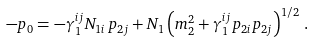Convert formula to latex. <formula><loc_0><loc_0><loc_500><loc_500>- p _ { 0 } = - \gamma ^ { i j } _ { 1 } N _ { 1 i } \, p _ { 2 j } + N _ { 1 } \left ( m _ { 2 } ^ { 2 } + \gamma ^ { i j } _ { 1 } p _ { 2 i } p _ { 2 j } \right ) ^ { 1 / 2 } \, .</formula> 